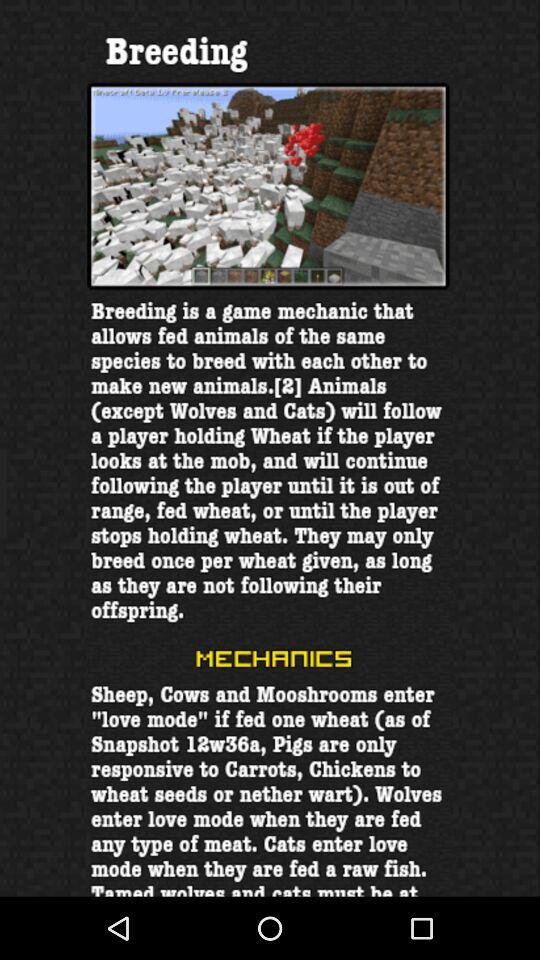How many types of animals can be tamed with wheat?
Answer the question using a single word or phrase. 3 